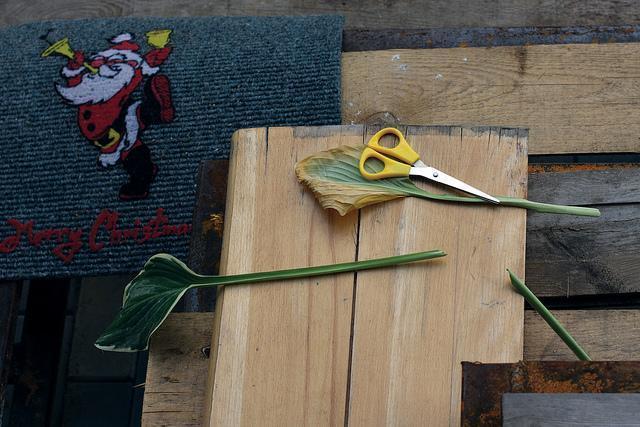How many people in the image are wearing bright green jackets?
Give a very brief answer. 0. 